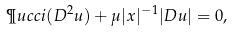<formula> <loc_0><loc_0><loc_500><loc_500>\P u c c i ( D ^ { 2 } u ) + \mu | x | ^ { - 1 } | D u | = 0 ,</formula> 